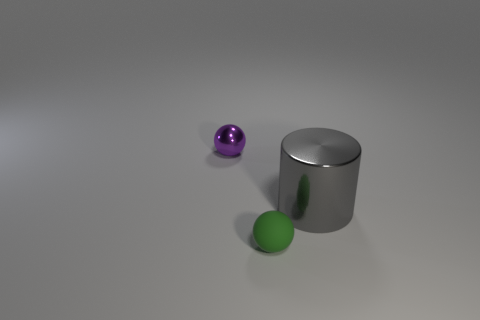Is the shape of the gray shiny thing the same as the tiny green matte thing?
Your response must be concise. No. What size is the ball in front of the small purple metallic ball?
Your answer should be compact. Small. There is a purple metallic thing; is it the same size as the object in front of the shiny cylinder?
Offer a very short reply. Yes. Is the number of metal objects behind the shiny sphere less than the number of big metallic objects?
Ensure brevity in your answer.  Yes. There is a purple object that is the same shape as the small green object; what is it made of?
Provide a succinct answer. Metal. What is the shape of the object that is both in front of the small purple metal ball and left of the big gray metallic object?
Your answer should be compact. Sphere. There is a gray object that is made of the same material as the small purple thing; what is its shape?
Ensure brevity in your answer.  Cylinder. What is the material of the ball that is in front of the large cylinder?
Your answer should be compact. Rubber. There is a ball in front of the tiny purple metallic thing; is its size the same as the metal thing that is in front of the small purple metallic sphere?
Make the answer very short. No. What is the color of the tiny rubber thing?
Give a very brief answer. Green. 